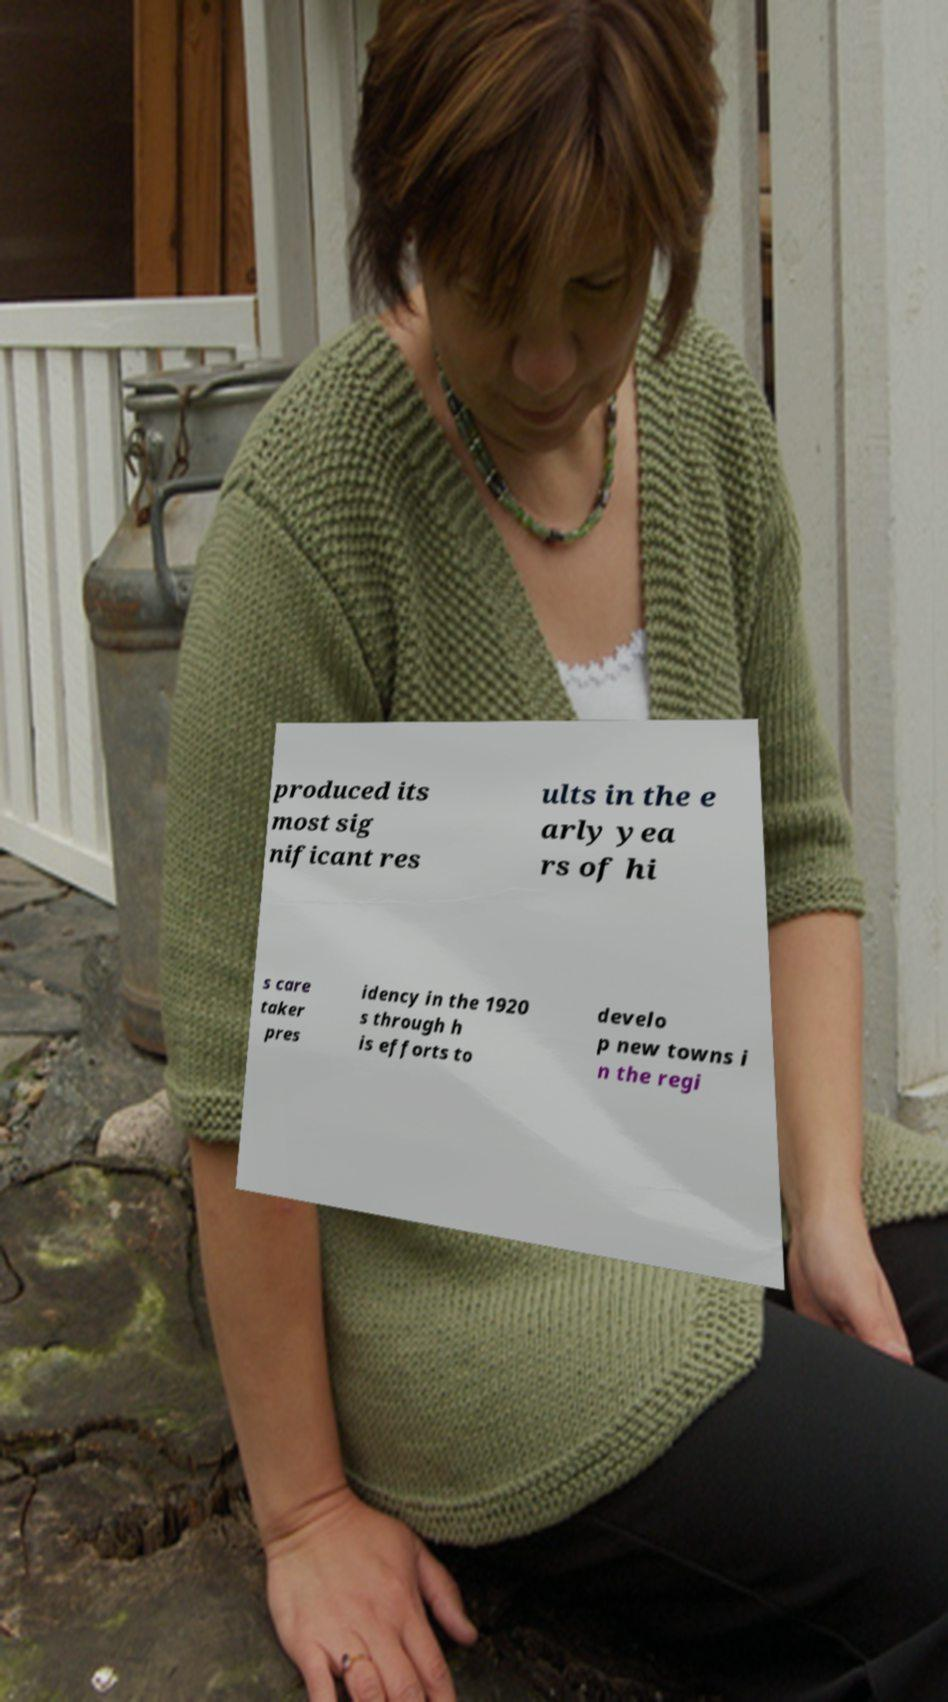Please identify and transcribe the text found in this image. produced its most sig nificant res ults in the e arly yea rs of hi s care taker pres idency in the 1920 s through h is efforts to develo p new towns i n the regi 